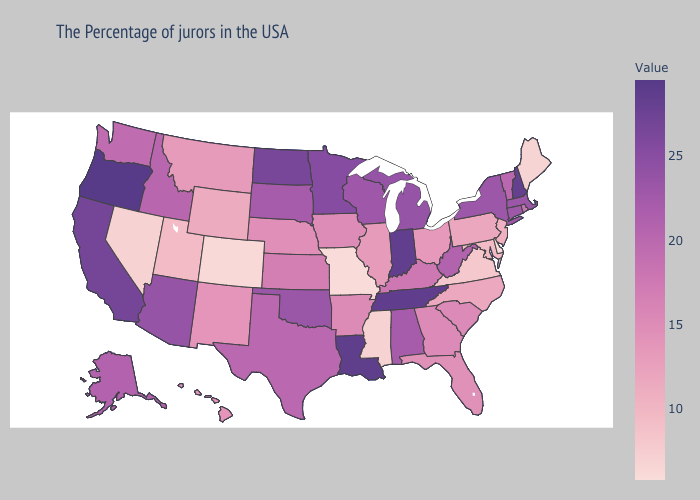Does Vermont have the highest value in the USA?
Be succinct. No. Does Arizona have a lower value than Idaho?
Answer briefly. No. Does Connecticut have the highest value in the USA?
Give a very brief answer. No. Does Louisiana have the highest value in the USA?
Keep it brief. No. Is the legend a continuous bar?
Give a very brief answer. Yes. Which states have the lowest value in the USA?
Give a very brief answer. Delaware. Among the states that border Minnesota , does Iowa have the lowest value?
Keep it brief. Yes. Does Kansas have a higher value than North Carolina?
Concise answer only. Yes. Among the states that border North Dakota , which have the lowest value?
Write a very short answer. Montana. 